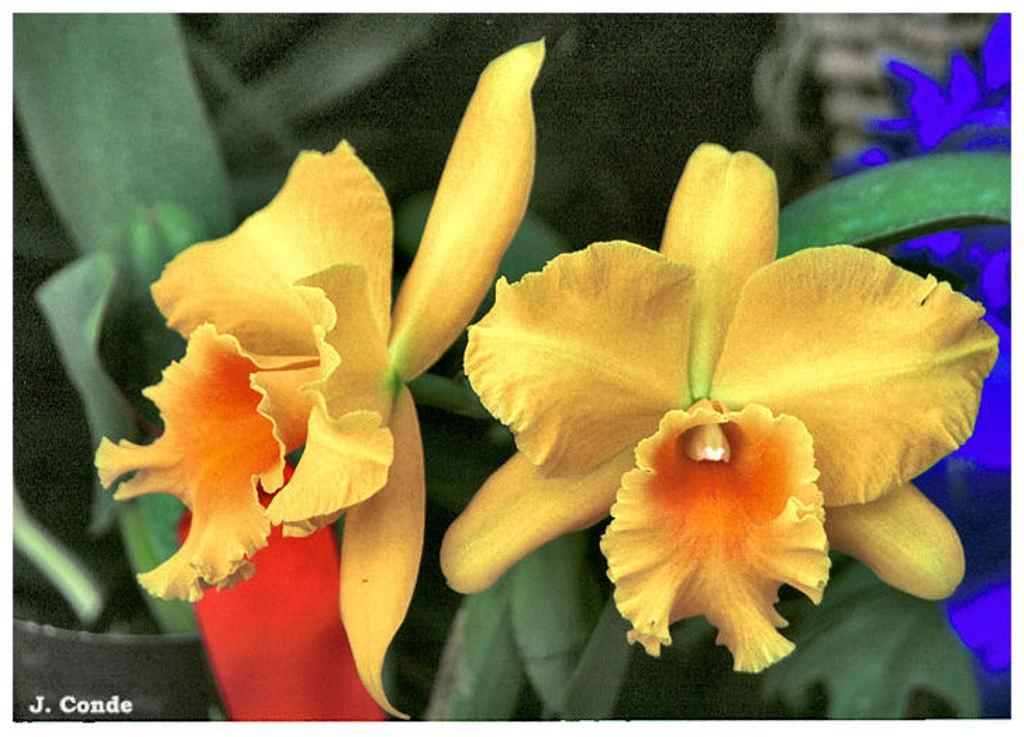Can you describe this image briefly? In this image we can see flowers, plants, and the background is blurred, also we can see the text on the image. 